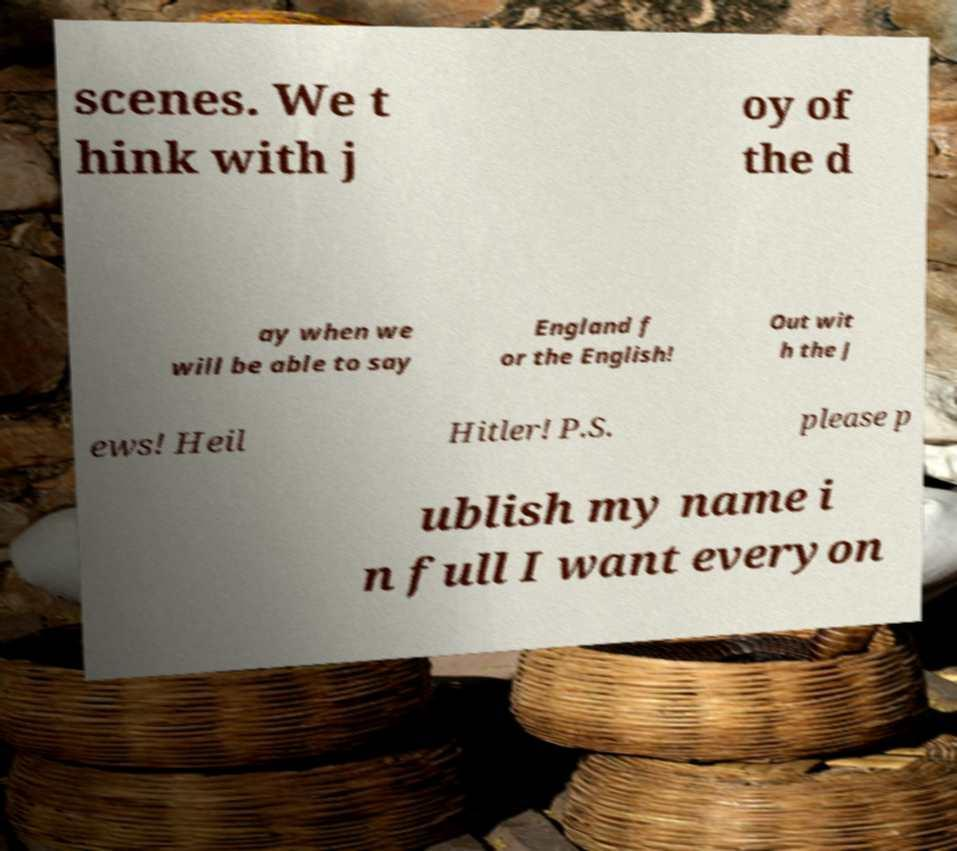For documentation purposes, I need the text within this image transcribed. Could you provide that? scenes. We t hink with j oy of the d ay when we will be able to say England f or the English! Out wit h the J ews! Heil Hitler! P.S. please p ublish my name i n full I want everyon 